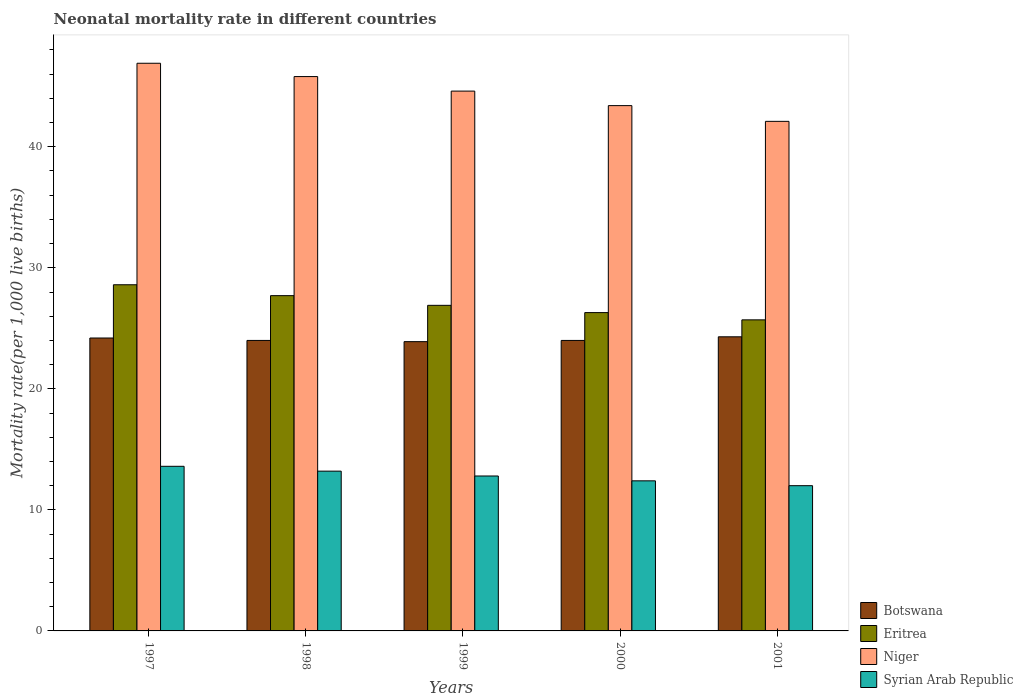How many groups of bars are there?
Offer a terse response. 5. How many bars are there on the 3rd tick from the right?
Your response must be concise. 4. What is the label of the 3rd group of bars from the left?
Ensure brevity in your answer.  1999. What is the neonatal mortality rate in Niger in 2000?
Provide a succinct answer. 43.4. Across all years, what is the maximum neonatal mortality rate in Botswana?
Your answer should be compact. 24.3. Across all years, what is the minimum neonatal mortality rate in Niger?
Your answer should be compact. 42.1. In which year was the neonatal mortality rate in Syrian Arab Republic maximum?
Make the answer very short. 1997. What is the total neonatal mortality rate in Eritrea in the graph?
Provide a succinct answer. 135.2. What is the difference between the neonatal mortality rate in Botswana in 1999 and that in 2000?
Your response must be concise. -0.1. What is the difference between the neonatal mortality rate in Niger in 1998 and the neonatal mortality rate in Eritrea in 1997?
Your response must be concise. 17.2. What is the average neonatal mortality rate in Syrian Arab Republic per year?
Provide a short and direct response. 12.8. In the year 1999, what is the difference between the neonatal mortality rate in Niger and neonatal mortality rate in Eritrea?
Make the answer very short. 17.7. In how many years, is the neonatal mortality rate in Syrian Arab Republic greater than 12?
Provide a succinct answer. 4. What is the ratio of the neonatal mortality rate in Botswana in 1997 to that in 1998?
Provide a short and direct response. 1.01. Is the neonatal mortality rate in Syrian Arab Republic in 1998 less than that in 2001?
Offer a terse response. No. Is the difference between the neonatal mortality rate in Niger in 1997 and 2000 greater than the difference between the neonatal mortality rate in Eritrea in 1997 and 2000?
Your answer should be very brief. Yes. What is the difference between the highest and the second highest neonatal mortality rate in Niger?
Offer a terse response. 1.1. What is the difference between the highest and the lowest neonatal mortality rate in Botswana?
Make the answer very short. 0.4. Is the sum of the neonatal mortality rate in Niger in 1997 and 1999 greater than the maximum neonatal mortality rate in Botswana across all years?
Your answer should be very brief. Yes. Is it the case that in every year, the sum of the neonatal mortality rate in Botswana and neonatal mortality rate in Eritrea is greater than the sum of neonatal mortality rate in Niger and neonatal mortality rate in Syrian Arab Republic?
Your answer should be very brief. No. What does the 3rd bar from the left in 1997 represents?
Your answer should be very brief. Niger. What does the 2nd bar from the right in 1997 represents?
Your answer should be compact. Niger. Does the graph contain any zero values?
Provide a succinct answer. No. Does the graph contain grids?
Your answer should be very brief. No. How are the legend labels stacked?
Give a very brief answer. Vertical. What is the title of the graph?
Offer a terse response. Neonatal mortality rate in different countries. Does "Chad" appear as one of the legend labels in the graph?
Provide a short and direct response. No. What is the label or title of the X-axis?
Keep it short and to the point. Years. What is the label or title of the Y-axis?
Your response must be concise. Mortality rate(per 1,0 live births). What is the Mortality rate(per 1,000 live births) in Botswana in 1997?
Provide a short and direct response. 24.2. What is the Mortality rate(per 1,000 live births) in Eritrea in 1997?
Offer a very short reply. 28.6. What is the Mortality rate(per 1,000 live births) of Niger in 1997?
Provide a short and direct response. 46.9. What is the Mortality rate(per 1,000 live births) in Syrian Arab Republic in 1997?
Make the answer very short. 13.6. What is the Mortality rate(per 1,000 live births) of Eritrea in 1998?
Keep it short and to the point. 27.7. What is the Mortality rate(per 1,000 live births) in Niger in 1998?
Your response must be concise. 45.8. What is the Mortality rate(per 1,000 live births) of Botswana in 1999?
Keep it short and to the point. 23.9. What is the Mortality rate(per 1,000 live births) of Eritrea in 1999?
Provide a succinct answer. 26.9. What is the Mortality rate(per 1,000 live births) in Niger in 1999?
Give a very brief answer. 44.6. What is the Mortality rate(per 1,000 live births) of Syrian Arab Republic in 1999?
Keep it short and to the point. 12.8. What is the Mortality rate(per 1,000 live births) of Botswana in 2000?
Your response must be concise. 24. What is the Mortality rate(per 1,000 live births) of Eritrea in 2000?
Offer a very short reply. 26.3. What is the Mortality rate(per 1,000 live births) in Niger in 2000?
Make the answer very short. 43.4. What is the Mortality rate(per 1,000 live births) of Syrian Arab Republic in 2000?
Offer a very short reply. 12.4. What is the Mortality rate(per 1,000 live births) of Botswana in 2001?
Offer a very short reply. 24.3. What is the Mortality rate(per 1,000 live births) of Eritrea in 2001?
Provide a succinct answer. 25.7. What is the Mortality rate(per 1,000 live births) in Niger in 2001?
Offer a very short reply. 42.1. What is the Mortality rate(per 1,000 live births) in Syrian Arab Republic in 2001?
Offer a terse response. 12. Across all years, what is the maximum Mortality rate(per 1,000 live births) of Botswana?
Offer a very short reply. 24.3. Across all years, what is the maximum Mortality rate(per 1,000 live births) of Eritrea?
Offer a terse response. 28.6. Across all years, what is the maximum Mortality rate(per 1,000 live births) in Niger?
Keep it short and to the point. 46.9. Across all years, what is the minimum Mortality rate(per 1,000 live births) of Botswana?
Give a very brief answer. 23.9. Across all years, what is the minimum Mortality rate(per 1,000 live births) in Eritrea?
Your answer should be compact. 25.7. Across all years, what is the minimum Mortality rate(per 1,000 live births) of Niger?
Ensure brevity in your answer.  42.1. Across all years, what is the minimum Mortality rate(per 1,000 live births) of Syrian Arab Republic?
Ensure brevity in your answer.  12. What is the total Mortality rate(per 1,000 live births) of Botswana in the graph?
Keep it short and to the point. 120.4. What is the total Mortality rate(per 1,000 live births) in Eritrea in the graph?
Give a very brief answer. 135.2. What is the total Mortality rate(per 1,000 live births) in Niger in the graph?
Your answer should be compact. 222.8. What is the total Mortality rate(per 1,000 live births) of Syrian Arab Republic in the graph?
Ensure brevity in your answer.  64. What is the difference between the Mortality rate(per 1,000 live births) in Eritrea in 1997 and that in 1998?
Offer a very short reply. 0.9. What is the difference between the Mortality rate(per 1,000 live births) of Botswana in 1997 and that in 1999?
Keep it short and to the point. 0.3. What is the difference between the Mortality rate(per 1,000 live births) of Syrian Arab Republic in 1997 and that in 1999?
Give a very brief answer. 0.8. What is the difference between the Mortality rate(per 1,000 live births) of Botswana in 1997 and that in 2000?
Offer a terse response. 0.2. What is the difference between the Mortality rate(per 1,000 live births) in Botswana in 1997 and that in 2001?
Make the answer very short. -0.1. What is the difference between the Mortality rate(per 1,000 live births) in Eritrea in 1997 and that in 2001?
Offer a very short reply. 2.9. What is the difference between the Mortality rate(per 1,000 live births) in Niger in 1997 and that in 2001?
Ensure brevity in your answer.  4.8. What is the difference between the Mortality rate(per 1,000 live births) in Niger in 1998 and that in 1999?
Your answer should be very brief. 1.2. What is the difference between the Mortality rate(per 1,000 live births) in Niger in 1998 and that in 2000?
Make the answer very short. 2.4. What is the difference between the Mortality rate(per 1,000 live births) in Syrian Arab Republic in 1998 and that in 2000?
Your answer should be compact. 0.8. What is the difference between the Mortality rate(per 1,000 live births) of Syrian Arab Republic in 1998 and that in 2001?
Your answer should be very brief. 1.2. What is the difference between the Mortality rate(per 1,000 live births) in Botswana in 1999 and that in 2000?
Your response must be concise. -0.1. What is the difference between the Mortality rate(per 1,000 live births) of Niger in 1999 and that in 2000?
Provide a short and direct response. 1.2. What is the difference between the Mortality rate(per 1,000 live births) in Syrian Arab Republic in 1999 and that in 2000?
Your answer should be very brief. 0.4. What is the difference between the Mortality rate(per 1,000 live births) in Botswana in 1999 and that in 2001?
Keep it short and to the point. -0.4. What is the difference between the Mortality rate(per 1,000 live births) in Syrian Arab Republic in 1999 and that in 2001?
Offer a very short reply. 0.8. What is the difference between the Mortality rate(per 1,000 live births) in Syrian Arab Republic in 2000 and that in 2001?
Your answer should be compact. 0.4. What is the difference between the Mortality rate(per 1,000 live births) in Botswana in 1997 and the Mortality rate(per 1,000 live births) in Niger in 1998?
Your answer should be very brief. -21.6. What is the difference between the Mortality rate(per 1,000 live births) in Botswana in 1997 and the Mortality rate(per 1,000 live births) in Syrian Arab Republic in 1998?
Your response must be concise. 11. What is the difference between the Mortality rate(per 1,000 live births) of Eritrea in 1997 and the Mortality rate(per 1,000 live births) of Niger in 1998?
Provide a succinct answer. -17.2. What is the difference between the Mortality rate(per 1,000 live births) in Niger in 1997 and the Mortality rate(per 1,000 live births) in Syrian Arab Republic in 1998?
Keep it short and to the point. 33.7. What is the difference between the Mortality rate(per 1,000 live births) of Botswana in 1997 and the Mortality rate(per 1,000 live births) of Eritrea in 1999?
Ensure brevity in your answer.  -2.7. What is the difference between the Mortality rate(per 1,000 live births) of Botswana in 1997 and the Mortality rate(per 1,000 live births) of Niger in 1999?
Give a very brief answer. -20.4. What is the difference between the Mortality rate(per 1,000 live births) of Botswana in 1997 and the Mortality rate(per 1,000 live births) of Syrian Arab Republic in 1999?
Your answer should be very brief. 11.4. What is the difference between the Mortality rate(per 1,000 live births) of Eritrea in 1997 and the Mortality rate(per 1,000 live births) of Syrian Arab Republic in 1999?
Give a very brief answer. 15.8. What is the difference between the Mortality rate(per 1,000 live births) of Niger in 1997 and the Mortality rate(per 1,000 live births) of Syrian Arab Republic in 1999?
Keep it short and to the point. 34.1. What is the difference between the Mortality rate(per 1,000 live births) of Botswana in 1997 and the Mortality rate(per 1,000 live births) of Niger in 2000?
Offer a very short reply. -19.2. What is the difference between the Mortality rate(per 1,000 live births) in Botswana in 1997 and the Mortality rate(per 1,000 live births) in Syrian Arab Republic in 2000?
Ensure brevity in your answer.  11.8. What is the difference between the Mortality rate(per 1,000 live births) in Eritrea in 1997 and the Mortality rate(per 1,000 live births) in Niger in 2000?
Your answer should be very brief. -14.8. What is the difference between the Mortality rate(per 1,000 live births) in Niger in 1997 and the Mortality rate(per 1,000 live births) in Syrian Arab Republic in 2000?
Give a very brief answer. 34.5. What is the difference between the Mortality rate(per 1,000 live births) of Botswana in 1997 and the Mortality rate(per 1,000 live births) of Eritrea in 2001?
Provide a short and direct response. -1.5. What is the difference between the Mortality rate(per 1,000 live births) in Botswana in 1997 and the Mortality rate(per 1,000 live births) in Niger in 2001?
Make the answer very short. -17.9. What is the difference between the Mortality rate(per 1,000 live births) of Botswana in 1997 and the Mortality rate(per 1,000 live births) of Syrian Arab Republic in 2001?
Offer a terse response. 12.2. What is the difference between the Mortality rate(per 1,000 live births) in Eritrea in 1997 and the Mortality rate(per 1,000 live births) in Niger in 2001?
Make the answer very short. -13.5. What is the difference between the Mortality rate(per 1,000 live births) of Eritrea in 1997 and the Mortality rate(per 1,000 live births) of Syrian Arab Republic in 2001?
Provide a short and direct response. 16.6. What is the difference between the Mortality rate(per 1,000 live births) of Niger in 1997 and the Mortality rate(per 1,000 live births) of Syrian Arab Republic in 2001?
Your answer should be compact. 34.9. What is the difference between the Mortality rate(per 1,000 live births) of Botswana in 1998 and the Mortality rate(per 1,000 live births) of Eritrea in 1999?
Your answer should be compact. -2.9. What is the difference between the Mortality rate(per 1,000 live births) of Botswana in 1998 and the Mortality rate(per 1,000 live births) of Niger in 1999?
Ensure brevity in your answer.  -20.6. What is the difference between the Mortality rate(per 1,000 live births) in Eritrea in 1998 and the Mortality rate(per 1,000 live births) in Niger in 1999?
Provide a short and direct response. -16.9. What is the difference between the Mortality rate(per 1,000 live births) in Niger in 1998 and the Mortality rate(per 1,000 live births) in Syrian Arab Republic in 1999?
Keep it short and to the point. 33. What is the difference between the Mortality rate(per 1,000 live births) in Botswana in 1998 and the Mortality rate(per 1,000 live births) in Eritrea in 2000?
Ensure brevity in your answer.  -2.3. What is the difference between the Mortality rate(per 1,000 live births) in Botswana in 1998 and the Mortality rate(per 1,000 live births) in Niger in 2000?
Your answer should be compact. -19.4. What is the difference between the Mortality rate(per 1,000 live births) of Botswana in 1998 and the Mortality rate(per 1,000 live births) of Syrian Arab Republic in 2000?
Give a very brief answer. 11.6. What is the difference between the Mortality rate(per 1,000 live births) of Eritrea in 1998 and the Mortality rate(per 1,000 live births) of Niger in 2000?
Provide a short and direct response. -15.7. What is the difference between the Mortality rate(per 1,000 live births) of Eritrea in 1998 and the Mortality rate(per 1,000 live births) of Syrian Arab Republic in 2000?
Provide a short and direct response. 15.3. What is the difference between the Mortality rate(per 1,000 live births) of Niger in 1998 and the Mortality rate(per 1,000 live births) of Syrian Arab Republic in 2000?
Offer a very short reply. 33.4. What is the difference between the Mortality rate(per 1,000 live births) of Botswana in 1998 and the Mortality rate(per 1,000 live births) of Niger in 2001?
Give a very brief answer. -18.1. What is the difference between the Mortality rate(per 1,000 live births) in Botswana in 1998 and the Mortality rate(per 1,000 live births) in Syrian Arab Republic in 2001?
Provide a short and direct response. 12. What is the difference between the Mortality rate(per 1,000 live births) of Eritrea in 1998 and the Mortality rate(per 1,000 live births) of Niger in 2001?
Offer a terse response. -14.4. What is the difference between the Mortality rate(per 1,000 live births) in Eritrea in 1998 and the Mortality rate(per 1,000 live births) in Syrian Arab Republic in 2001?
Keep it short and to the point. 15.7. What is the difference between the Mortality rate(per 1,000 live births) of Niger in 1998 and the Mortality rate(per 1,000 live births) of Syrian Arab Republic in 2001?
Make the answer very short. 33.8. What is the difference between the Mortality rate(per 1,000 live births) in Botswana in 1999 and the Mortality rate(per 1,000 live births) in Niger in 2000?
Keep it short and to the point. -19.5. What is the difference between the Mortality rate(per 1,000 live births) of Eritrea in 1999 and the Mortality rate(per 1,000 live births) of Niger in 2000?
Make the answer very short. -16.5. What is the difference between the Mortality rate(per 1,000 live births) of Eritrea in 1999 and the Mortality rate(per 1,000 live births) of Syrian Arab Republic in 2000?
Give a very brief answer. 14.5. What is the difference between the Mortality rate(per 1,000 live births) in Niger in 1999 and the Mortality rate(per 1,000 live births) in Syrian Arab Republic in 2000?
Offer a very short reply. 32.2. What is the difference between the Mortality rate(per 1,000 live births) in Botswana in 1999 and the Mortality rate(per 1,000 live births) in Niger in 2001?
Ensure brevity in your answer.  -18.2. What is the difference between the Mortality rate(per 1,000 live births) of Botswana in 1999 and the Mortality rate(per 1,000 live births) of Syrian Arab Republic in 2001?
Offer a very short reply. 11.9. What is the difference between the Mortality rate(per 1,000 live births) of Eritrea in 1999 and the Mortality rate(per 1,000 live births) of Niger in 2001?
Your response must be concise. -15.2. What is the difference between the Mortality rate(per 1,000 live births) of Niger in 1999 and the Mortality rate(per 1,000 live births) of Syrian Arab Republic in 2001?
Keep it short and to the point. 32.6. What is the difference between the Mortality rate(per 1,000 live births) of Botswana in 2000 and the Mortality rate(per 1,000 live births) of Niger in 2001?
Keep it short and to the point. -18.1. What is the difference between the Mortality rate(per 1,000 live births) in Eritrea in 2000 and the Mortality rate(per 1,000 live births) in Niger in 2001?
Give a very brief answer. -15.8. What is the difference between the Mortality rate(per 1,000 live births) in Niger in 2000 and the Mortality rate(per 1,000 live births) in Syrian Arab Republic in 2001?
Make the answer very short. 31.4. What is the average Mortality rate(per 1,000 live births) in Botswana per year?
Offer a terse response. 24.08. What is the average Mortality rate(per 1,000 live births) of Eritrea per year?
Make the answer very short. 27.04. What is the average Mortality rate(per 1,000 live births) of Niger per year?
Give a very brief answer. 44.56. In the year 1997, what is the difference between the Mortality rate(per 1,000 live births) in Botswana and Mortality rate(per 1,000 live births) in Niger?
Make the answer very short. -22.7. In the year 1997, what is the difference between the Mortality rate(per 1,000 live births) of Eritrea and Mortality rate(per 1,000 live births) of Niger?
Ensure brevity in your answer.  -18.3. In the year 1997, what is the difference between the Mortality rate(per 1,000 live births) in Eritrea and Mortality rate(per 1,000 live births) in Syrian Arab Republic?
Ensure brevity in your answer.  15. In the year 1997, what is the difference between the Mortality rate(per 1,000 live births) of Niger and Mortality rate(per 1,000 live births) of Syrian Arab Republic?
Provide a short and direct response. 33.3. In the year 1998, what is the difference between the Mortality rate(per 1,000 live births) of Botswana and Mortality rate(per 1,000 live births) of Niger?
Ensure brevity in your answer.  -21.8. In the year 1998, what is the difference between the Mortality rate(per 1,000 live births) in Botswana and Mortality rate(per 1,000 live births) in Syrian Arab Republic?
Ensure brevity in your answer.  10.8. In the year 1998, what is the difference between the Mortality rate(per 1,000 live births) of Eritrea and Mortality rate(per 1,000 live births) of Niger?
Your response must be concise. -18.1. In the year 1998, what is the difference between the Mortality rate(per 1,000 live births) of Eritrea and Mortality rate(per 1,000 live births) of Syrian Arab Republic?
Provide a succinct answer. 14.5. In the year 1998, what is the difference between the Mortality rate(per 1,000 live births) of Niger and Mortality rate(per 1,000 live births) of Syrian Arab Republic?
Offer a very short reply. 32.6. In the year 1999, what is the difference between the Mortality rate(per 1,000 live births) in Botswana and Mortality rate(per 1,000 live births) in Eritrea?
Offer a terse response. -3. In the year 1999, what is the difference between the Mortality rate(per 1,000 live births) in Botswana and Mortality rate(per 1,000 live births) in Niger?
Provide a succinct answer. -20.7. In the year 1999, what is the difference between the Mortality rate(per 1,000 live births) in Eritrea and Mortality rate(per 1,000 live births) in Niger?
Provide a succinct answer. -17.7. In the year 1999, what is the difference between the Mortality rate(per 1,000 live births) in Eritrea and Mortality rate(per 1,000 live births) in Syrian Arab Republic?
Offer a very short reply. 14.1. In the year 1999, what is the difference between the Mortality rate(per 1,000 live births) of Niger and Mortality rate(per 1,000 live births) of Syrian Arab Republic?
Provide a short and direct response. 31.8. In the year 2000, what is the difference between the Mortality rate(per 1,000 live births) of Botswana and Mortality rate(per 1,000 live births) of Eritrea?
Offer a terse response. -2.3. In the year 2000, what is the difference between the Mortality rate(per 1,000 live births) in Botswana and Mortality rate(per 1,000 live births) in Niger?
Offer a terse response. -19.4. In the year 2000, what is the difference between the Mortality rate(per 1,000 live births) in Botswana and Mortality rate(per 1,000 live births) in Syrian Arab Republic?
Provide a succinct answer. 11.6. In the year 2000, what is the difference between the Mortality rate(per 1,000 live births) in Eritrea and Mortality rate(per 1,000 live births) in Niger?
Make the answer very short. -17.1. In the year 2000, what is the difference between the Mortality rate(per 1,000 live births) in Eritrea and Mortality rate(per 1,000 live births) in Syrian Arab Republic?
Offer a terse response. 13.9. In the year 2001, what is the difference between the Mortality rate(per 1,000 live births) of Botswana and Mortality rate(per 1,000 live births) of Niger?
Offer a very short reply. -17.8. In the year 2001, what is the difference between the Mortality rate(per 1,000 live births) in Botswana and Mortality rate(per 1,000 live births) in Syrian Arab Republic?
Offer a terse response. 12.3. In the year 2001, what is the difference between the Mortality rate(per 1,000 live births) of Eritrea and Mortality rate(per 1,000 live births) of Niger?
Provide a short and direct response. -16.4. In the year 2001, what is the difference between the Mortality rate(per 1,000 live births) of Niger and Mortality rate(per 1,000 live births) of Syrian Arab Republic?
Provide a short and direct response. 30.1. What is the ratio of the Mortality rate(per 1,000 live births) of Botswana in 1997 to that in 1998?
Ensure brevity in your answer.  1.01. What is the ratio of the Mortality rate(per 1,000 live births) in Eritrea in 1997 to that in 1998?
Offer a very short reply. 1.03. What is the ratio of the Mortality rate(per 1,000 live births) in Syrian Arab Republic in 1997 to that in 1998?
Offer a terse response. 1.03. What is the ratio of the Mortality rate(per 1,000 live births) in Botswana in 1997 to that in 1999?
Your answer should be very brief. 1.01. What is the ratio of the Mortality rate(per 1,000 live births) of Eritrea in 1997 to that in 1999?
Provide a short and direct response. 1.06. What is the ratio of the Mortality rate(per 1,000 live births) of Niger in 1997 to that in 1999?
Your response must be concise. 1.05. What is the ratio of the Mortality rate(per 1,000 live births) in Syrian Arab Republic in 1997 to that in 1999?
Make the answer very short. 1.06. What is the ratio of the Mortality rate(per 1,000 live births) in Botswana in 1997 to that in 2000?
Make the answer very short. 1.01. What is the ratio of the Mortality rate(per 1,000 live births) in Eritrea in 1997 to that in 2000?
Provide a short and direct response. 1.09. What is the ratio of the Mortality rate(per 1,000 live births) of Niger in 1997 to that in 2000?
Keep it short and to the point. 1.08. What is the ratio of the Mortality rate(per 1,000 live births) of Syrian Arab Republic in 1997 to that in 2000?
Make the answer very short. 1.1. What is the ratio of the Mortality rate(per 1,000 live births) in Botswana in 1997 to that in 2001?
Your answer should be compact. 1. What is the ratio of the Mortality rate(per 1,000 live births) in Eritrea in 1997 to that in 2001?
Your response must be concise. 1.11. What is the ratio of the Mortality rate(per 1,000 live births) of Niger in 1997 to that in 2001?
Offer a very short reply. 1.11. What is the ratio of the Mortality rate(per 1,000 live births) in Syrian Arab Republic in 1997 to that in 2001?
Your answer should be very brief. 1.13. What is the ratio of the Mortality rate(per 1,000 live births) of Eritrea in 1998 to that in 1999?
Offer a terse response. 1.03. What is the ratio of the Mortality rate(per 1,000 live births) in Niger in 1998 to that in 1999?
Offer a very short reply. 1.03. What is the ratio of the Mortality rate(per 1,000 live births) of Syrian Arab Republic in 1998 to that in 1999?
Offer a terse response. 1.03. What is the ratio of the Mortality rate(per 1,000 live births) in Eritrea in 1998 to that in 2000?
Offer a very short reply. 1.05. What is the ratio of the Mortality rate(per 1,000 live births) in Niger in 1998 to that in 2000?
Offer a very short reply. 1.06. What is the ratio of the Mortality rate(per 1,000 live births) of Syrian Arab Republic in 1998 to that in 2000?
Keep it short and to the point. 1.06. What is the ratio of the Mortality rate(per 1,000 live births) in Eritrea in 1998 to that in 2001?
Keep it short and to the point. 1.08. What is the ratio of the Mortality rate(per 1,000 live births) in Niger in 1998 to that in 2001?
Ensure brevity in your answer.  1.09. What is the ratio of the Mortality rate(per 1,000 live births) of Syrian Arab Republic in 1998 to that in 2001?
Offer a very short reply. 1.1. What is the ratio of the Mortality rate(per 1,000 live births) of Eritrea in 1999 to that in 2000?
Provide a succinct answer. 1.02. What is the ratio of the Mortality rate(per 1,000 live births) in Niger in 1999 to that in 2000?
Offer a terse response. 1.03. What is the ratio of the Mortality rate(per 1,000 live births) of Syrian Arab Republic in 1999 to that in 2000?
Provide a short and direct response. 1.03. What is the ratio of the Mortality rate(per 1,000 live births) in Botswana in 1999 to that in 2001?
Ensure brevity in your answer.  0.98. What is the ratio of the Mortality rate(per 1,000 live births) in Eritrea in 1999 to that in 2001?
Your answer should be very brief. 1.05. What is the ratio of the Mortality rate(per 1,000 live births) of Niger in 1999 to that in 2001?
Offer a very short reply. 1.06. What is the ratio of the Mortality rate(per 1,000 live births) of Syrian Arab Republic in 1999 to that in 2001?
Make the answer very short. 1.07. What is the ratio of the Mortality rate(per 1,000 live births) of Botswana in 2000 to that in 2001?
Your answer should be very brief. 0.99. What is the ratio of the Mortality rate(per 1,000 live births) in Eritrea in 2000 to that in 2001?
Make the answer very short. 1.02. What is the ratio of the Mortality rate(per 1,000 live births) of Niger in 2000 to that in 2001?
Your answer should be compact. 1.03. What is the difference between the highest and the second highest Mortality rate(per 1,000 live births) in Niger?
Offer a very short reply. 1.1. What is the difference between the highest and the second highest Mortality rate(per 1,000 live births) in Syrian Arab Republic?
Offer a terse response. 0.4. What is the difference between the highest and the lowest Mortality rate(per 1,000 live births) of Eritrea?
Your answer should be compact. 2.9. What is the difference between the highest and the lowest Mortality rate(per 1,000 live births) of Syrian Arab Republic?
Give a very brief answer. 1.6. 